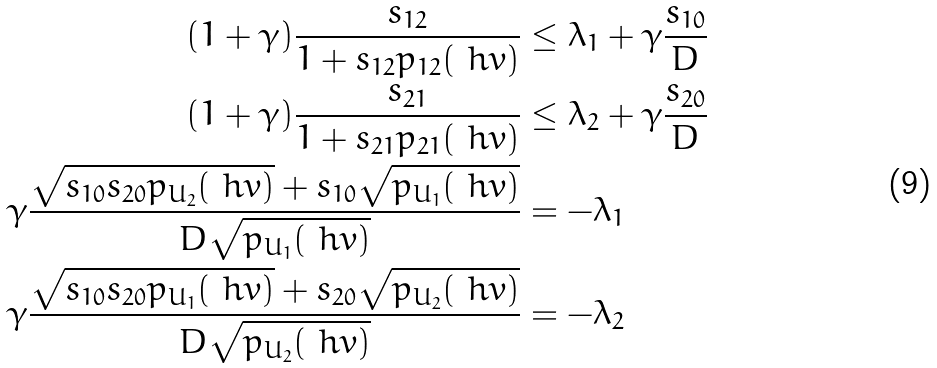Convert formula to latex. <formula><loc_0><loc_0><loc_500><loc_500>( 1 + \gamma ) \frac { s _ { 1 2 } } { 1 + s _ { 1 2 } p _ { 1 2 } ( \ h v ) } & \leq \lambda _ { 1 } + \gamma \frac { s _ { 1 0 } } { D } \\ ( 1 + \gamma ) \frac { s _ { 2 1 } } { 1 + s _ { 2 1 } p _ { 2 1 } ( \ h v ) } & \leq \lambda _ { 2 } + \gamma \frac { s _ { 2 0 } } { D } \\ \gamma \frac { \sqrt { s _ { 1 0 } s _ { 2 0 } p _ { U _ { 2 } } ( \ h v ) } + s _ { 1 0 } \sqrt { p _ { U _ { 1 } } ( \ h v ) } } { D \sqrt { p _ { U _ { 1 } } ( \ h v ) } } & = - \lambda _ { 1 } \\ \gamma \frac { \sqrt { s _ { 1 0 } s _ { 2 0 } p _ { U _ { 1 } } ( \ h v ) } + s _ { 2 0 } \sqrt { p _ { U _ { 2 } } ( \ h v ) } } { D \sqrt { p _ { U _ { 2 } } ( \ h v ) } } & = - \lambda _ { 2 }</formula> 